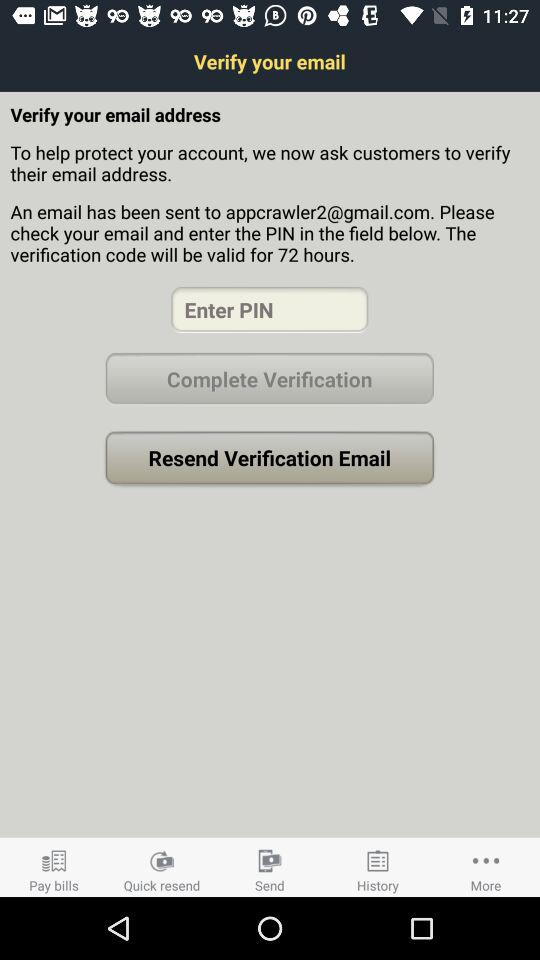How many hours is the verification code valid for?
Answer the question using a single word or phrase. 72 